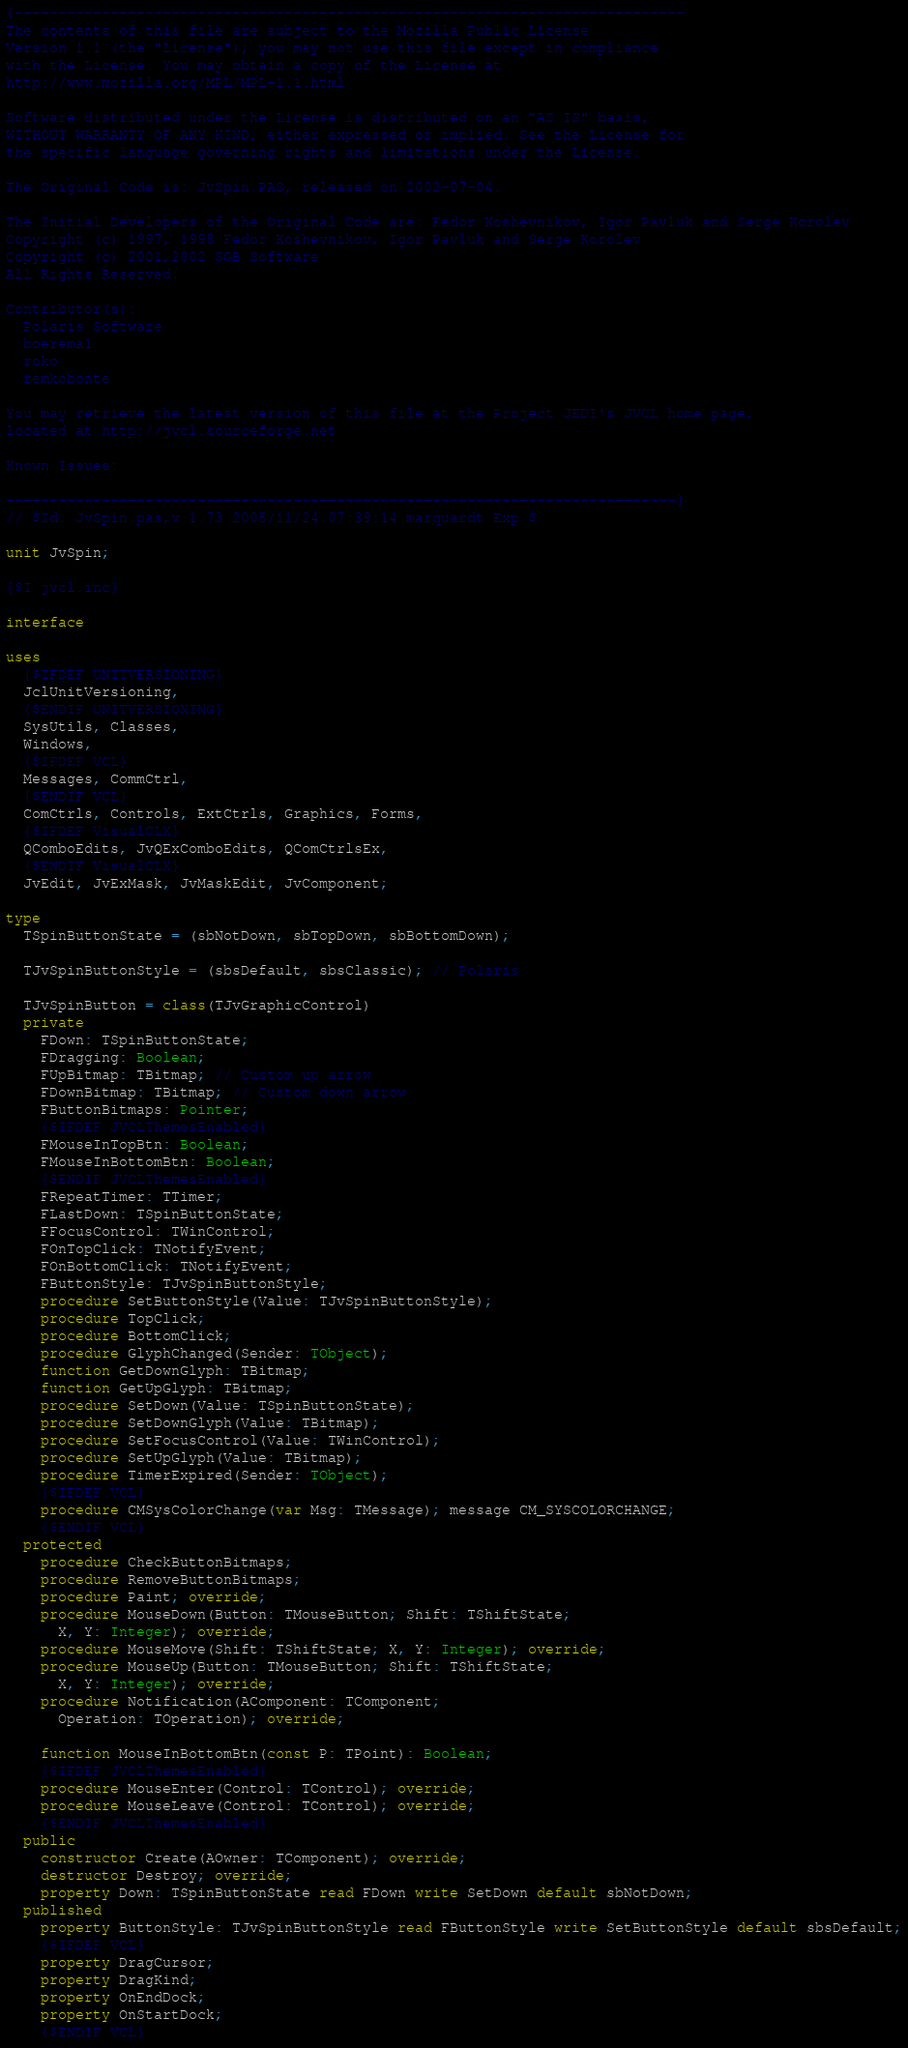Convert code to text. <code><loc_0><loc_0><loc_500><loc_500><_Pascal_>{-----------------------------------------------------------------------------
The contents of this file are subject to the Mozilla Public License
Version 1.1 (the "License"); you may not use this file except in compliance
with the License. You may obtain a copy of the License at
http://www.mozilla.org/MPL/MPL-1.1.html

Software distributed under the License is distributed on an "AS IS" basis,
WITHOUT WARRANTY OF ANY KIND, either expressed or implied. See the License for
the specific language governing rights and limitations under the License.

The Original Code is: JvSpin.PAS, released on 2002-07-04.

The Initial Developers of the Original Code are: Fedor Koshevnikov, Igor Pavluk and Serge Korolev
Copyright (c) 1997, 1998 Fedor Koshevnikov, Igor Pavluk and Serge Korolev
Copyright (c) 2001,2002 SGB Software
All Rights Reserved.

Contributor(s):
  Polaris Software
  boerema1
  roko
  remkobonte

You may retrieve the latest version of this file at the Project JEDI's JVCL home page,
located at http://jvcl.sourceforge.net

Known Issues:

-----------------------------------------------------------------------------}
// $Id: JvSpin.pas,v 1.73 2005/11/24 07:39:14 marquardt Exp $

unit JvSpin;

{$I jvcl.inc}

interface

uses
  {$IFDEF UNITVERSIONING}
  JclUnitVersioning,
  {$ENDIF UNITVERSIONING}
  SysUtils, Classes,
  Windows,
  {$IFDEF VCL}
  Messages, CommCtrl,
  {$ENDIF VCL}
  ComCtrls, Controls, ExtCtrls, Graphics, Forms,
  {$IFDEF VisualCLX}
  QComboEdits, JvQExComboEdits, QComCtrlsEx,
  {$ENDIF VisualCLX}
  JvEdit, JvExMask, JvMaskEdit, JvComponent;

type
  TSpinButtonState = (sbNotDown, sbTopDown, sbBottomDown);

  TJvSpinButtonStyle = (sbsDefault, sbsClassic); // Polaris

  TJvSpinButton = class(TJvGraphicControl)
  private
    FDown: TSpinButtonState;
    FDragging: Boolean;
    FUpBitmap: TBitmap; // Custom up arrow
    FDownBitmap: TBitmap; // Custom down arrow
    FButtonBitmaps: Pointer;
    {$IFDEF JVCLThemesEnabled}
    FMouseInTopBtn: Boolean;
    FMouseInBottomBtn: Boolean;
    {$ENDIF JVCLThemesEnabled}
    FRepeatTimer: TTimer;
    FLastDown: TSpinButtonState;
    FFocusControl: TWinControl;
    FOnTopClick: TNotifyEvent;
    FOnBottomClick: TNotifyEvent;
    FButtonStyle: TJvSpinButtonStyle;
    procedure SetButtonStyle(Value: TJvSpinButtonStyle);
    procedure TopClick;
    procedure BottomClick;
    procedure GlyphChanged(Sender: TObject);
    function GetDownGlyph: TBitmap;
    function GetUpGlyph: TBitmap;
    procedure SetDown(Value: TSpinButtonState);
    procedure SetDownGlyph(Value: TBitmap);
    procedure SetFocusControl(Value: TWinControl);
    procedure SetUpGlyph(Value: TBitmap);
    procedure TimerExpired(Sender: TObject);
    {$IFDEF VCL}
    procedure CMSysColorChange(var Msg: TMessage); message CM_SYSCOLORCHANGE;
    {$ENDIF VCL}
  protected
    procedure CheckButtonBitmaps;
    procedure RemoveButtonBitmaps;
    procedure Paint; override;
    procedure MouseDown(Button: TMouseButton; Shift: TShiftState;
      X, Y: Integer); override;
    procedure MouseMove(Shift: TShiftState; X, Y: Integer); override;
    procedure MouseUp(Button: TMouseButton; Shift: TShiftState;
      X, Y: Integer); override;
    procedure Notification(AComponent: TComponent;
      Operation: TOperation); override;

    function MouseInBottomBtn(const P: TPoint): Boolean;
    {$IFDEF JVCLThemesEnabled}
    procedure MouseEnter(Control: TControl); override;
    procedure MouseLeave(Control: TControl); override;
    {$ENDIF JVCLThemesEnabled}
  public
    constructor Create(AOwner: TComponent); override;
    destructor Destroy; override;
    property Down: TSpinButtonState read FDown write SetDown default sbNotDown;
  published
    property ButtonStyle: TJvSpinButtonStyle read FButtonStyle write SetButtonStyle default sbsDefault;
    {$IFDEF VCL}
    property DragCursor;
    property DragKind;
    property OnEndDock;
    property OnStartDock;
    {$ENDIF VCL}</code> 